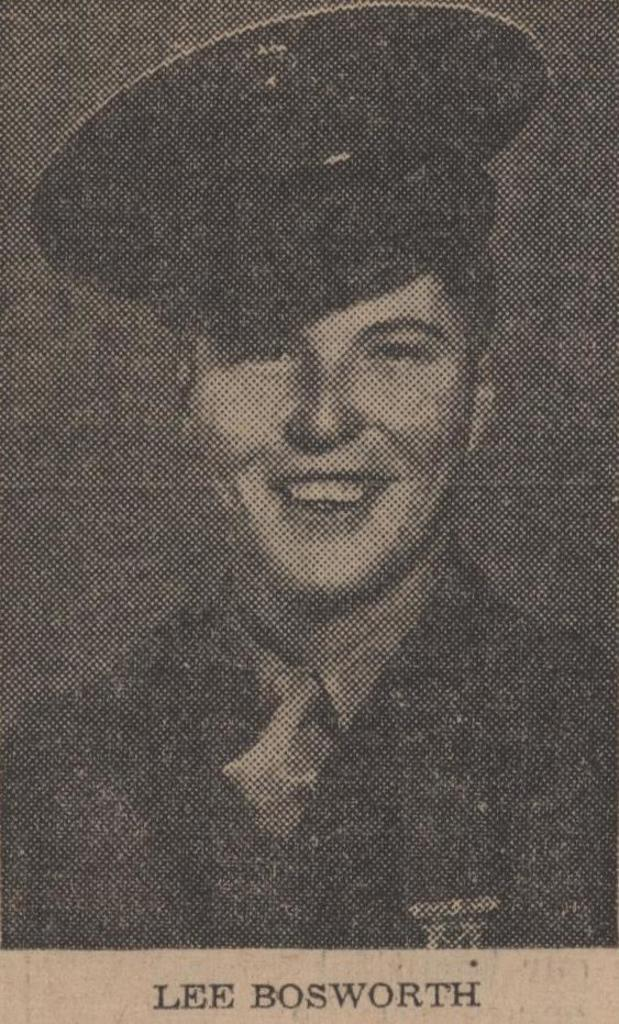What is present on the paper in the image? There is a person wearing a cap visible on the paper. What is the person on the paper doing? The person on the paper is smiling. Is there any text on the paper? Yes, there is a name at the bottom of the paper. What type of balls are being used to create the plot of the image? There is no plot or balls present in the image; it features a person wearing a cap on a paper with a name at the bottom. 